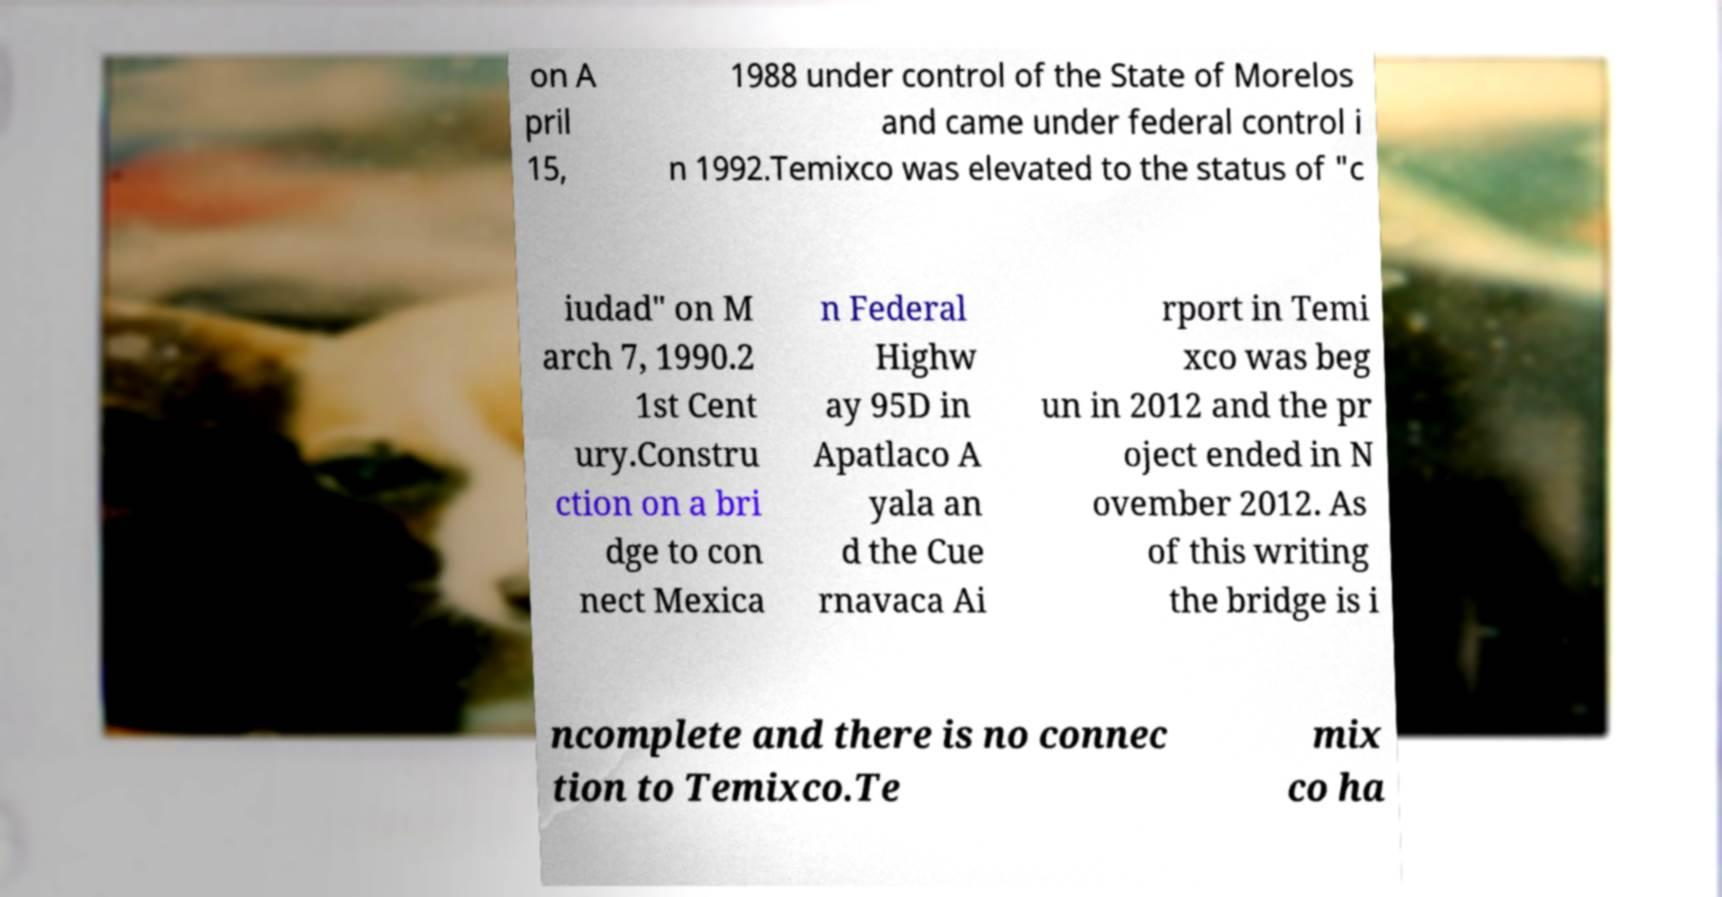For documentation purposes, I need the text within this image transcribed. Could you provide that? on A pril 15, 1988 under control of the State of Morelos and came under federal control i n 1992.Temixco was elevated to the status of "c iudad" on M arch 7, 1990.2 1st Cent ury.Constru ction on a bri dge to con nect Mexica n Federal Highw ay 95D in Apatlaco A yala an d the Cue rnavaca Ai rport in Temi xco was beg un in 2012 and the pr oject ended in N ovember 2012. As of this writing the bridge is i ncomplete and there is no connec tion to Temixco.Te mix co ha 